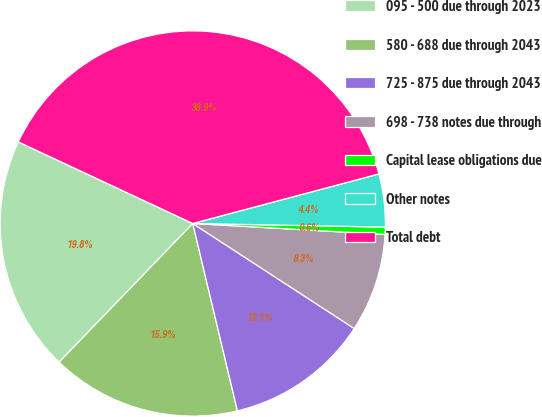Convert chart to OTSL. <chart><loc_0><loc_0><loc_500><loc_500><pie_chart><fcel>095 - 500 due through 2023<fcel>580 - 688 due through 2043<fcel>725 - 875 due through 2043<fcel>698 - 738 notes due through<fcel>Capital lease obligations due<fcel>Other notes<fcel>Total debt<nl><fcel>19.76%<fcel>15.93%<fcel>12.1%<fcel>8.27%<fcel>0.61%<fcel>4.44%<fcel>38.9%<nl></chart> 